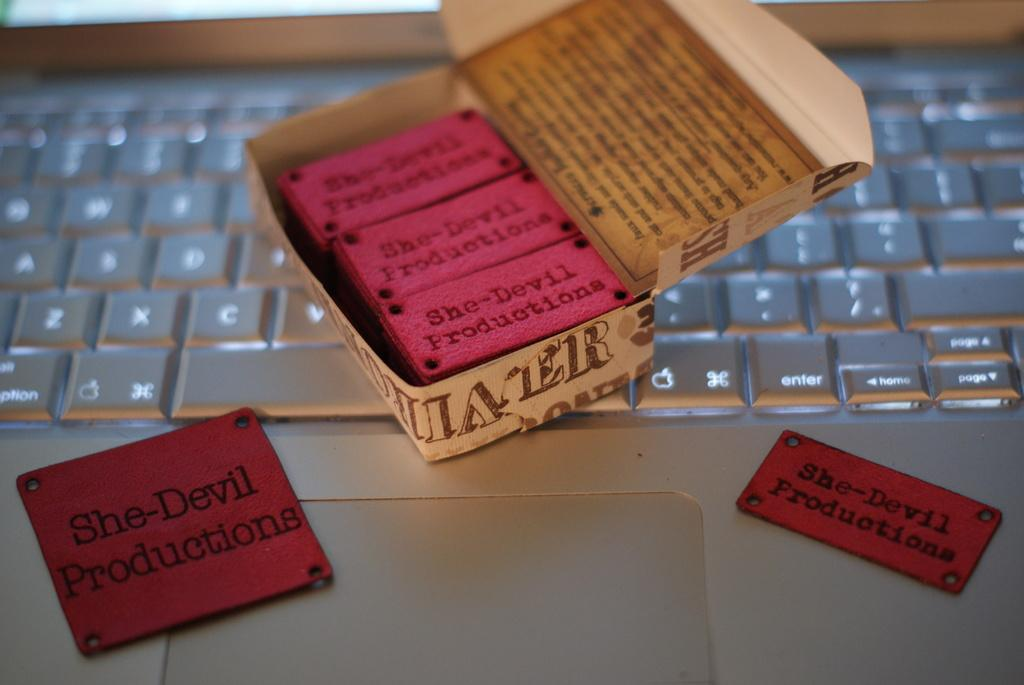<image>
Describe the image concisely. Several red tags with the words She-Devil productions on them 